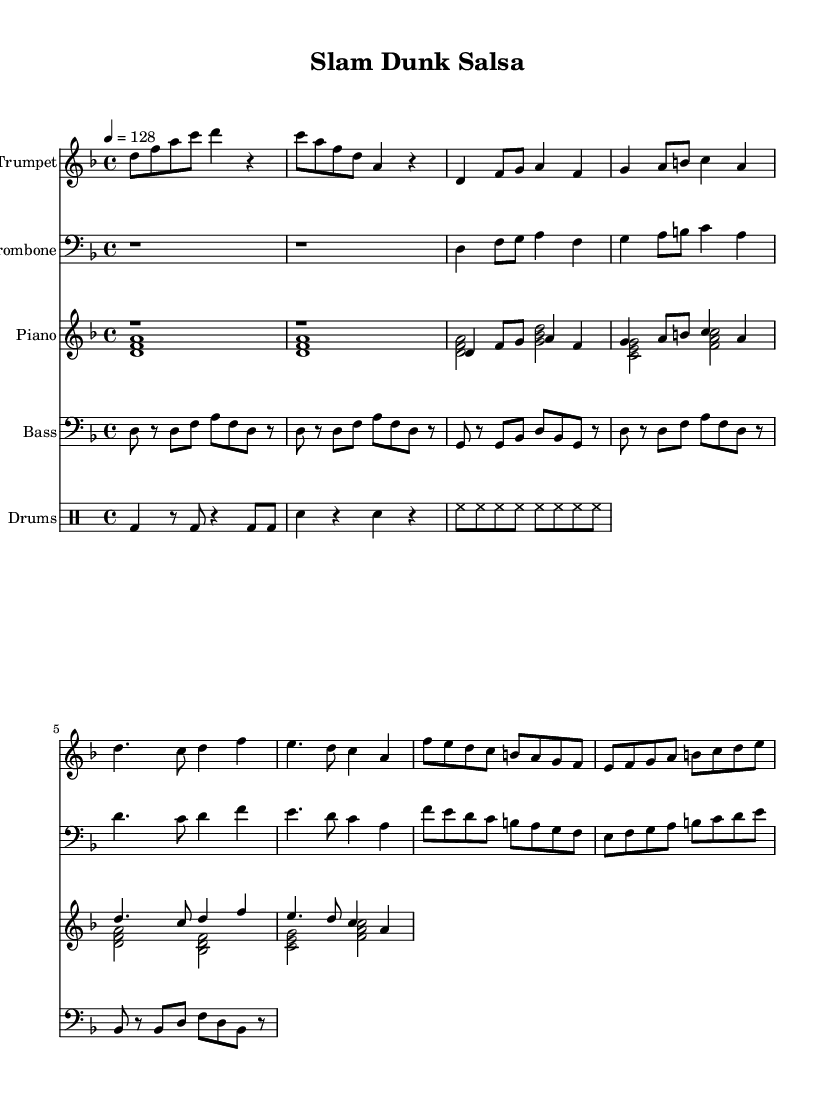What is the key signature of this music? The key signature is indicated at the beginning of the staff, where there are no sharps or flats, meaning it is in D minor.
Answer: D minor What is the time signature of this music? The time signature appears at the beginning of the sheet music, showing there are four beats per measure and the quarter note gets one beat.
Answer: 4/4 What is the tempo marking for this piece? The tempo marking is provided above the score, showing a tempo of 128 beats per minute, which is typical for a high-energy piece.
Answer: 128 How many instruments are present in this composition? By examining the score, there are five distinct instruments represented: trumpet, trombone, piano, bass, and drums.
Answer: Five What is the primary rhythmic pattern for the drums? The drum part shows a basic pattern of bass drum, snare drum, and hi-hat, with bass on the quarter notes and hi-hat playing eighth notes throughout.
Answer: Bass, snare, hi-hat Which instrument plays the highest melody? Looking at the score, the trumpet part is written in the treble clef and is pitched higher than the other parts, indicating it carries the highest melody.
Answer: Trumpet What fusion genres influence this piece? The title "Slam Dunk Salsa" suggests that this composition blends funk rhythms with Latin influences, reflecting a fun and energetic workout style.
Answer: Funk, Latin 